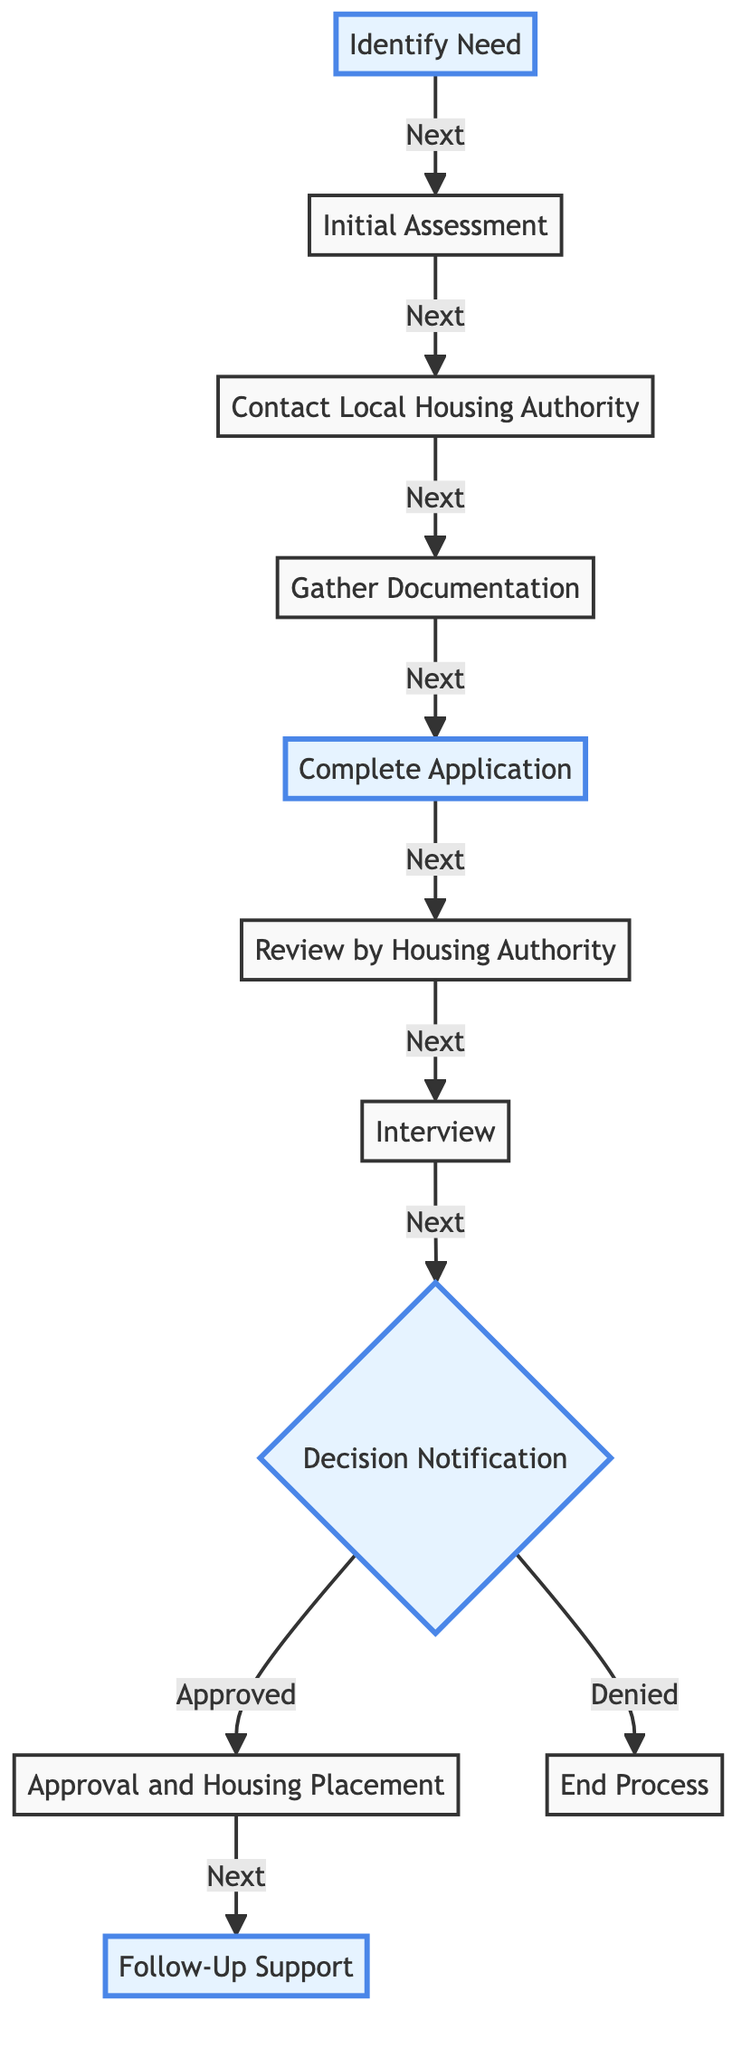What is the first step in the process? The first step is "Identify Need," as indicated by the starting node at the top of the flow chart.
Answer: Identify Need How many main steps are there in the process? Counting the steps listed in the diagram, there are a total of 10 main steps, including both the initial steps and the final outcomes.
Answer: 10 What happens after the "Complete Application" step? After "Complete Application," the next step indicated in the flowchart is "Review by Housing Authority." This shows the progression of the process.
Answer: Review by Housing Authority What decision is made after the "Interview" step? The next node after "Interview" is "Decision Notification," which indicates that a decision regarding the application is made following the interview.
Answer: Decision Notification What do you receive if your application is approved? If the application is approved, the next step indicated is "Approval and Housing Placement," meaning you would receive assistance for housing placement.
Answer: Approval and Housing Placement What is the alternative outcome if the application is denied? If the application is denied, the flowchart indicates that the process ends, as shown by the "End Process" node.
Answer: End Process Which step involves gathering necessary documents? The step where necessary documents are gathered is "Gather Documentation"; it follows the step of contacting the local housing authority.
Answer: Gather Documentation How many paths are there leading from the "Decision Notification" step? There are two possible paths from the "Decision Notification" step: one leading to "Approval and Housing Placement" if approved, and one leading to "End Process" if denied.
Answer: 2 What support is available after approval? After the approval, the flowchart indicates "Follow-Up Support" as the subsequent step, signifying the availability of additional services.
Answer: Follow-Up Support What is the purpose of the "Initial Assessment" step? The purpose of the "Initial Assessment" is to collect important information about the applicant, such as income and family size, relevant for processing the application.
Answer: Collect important information 